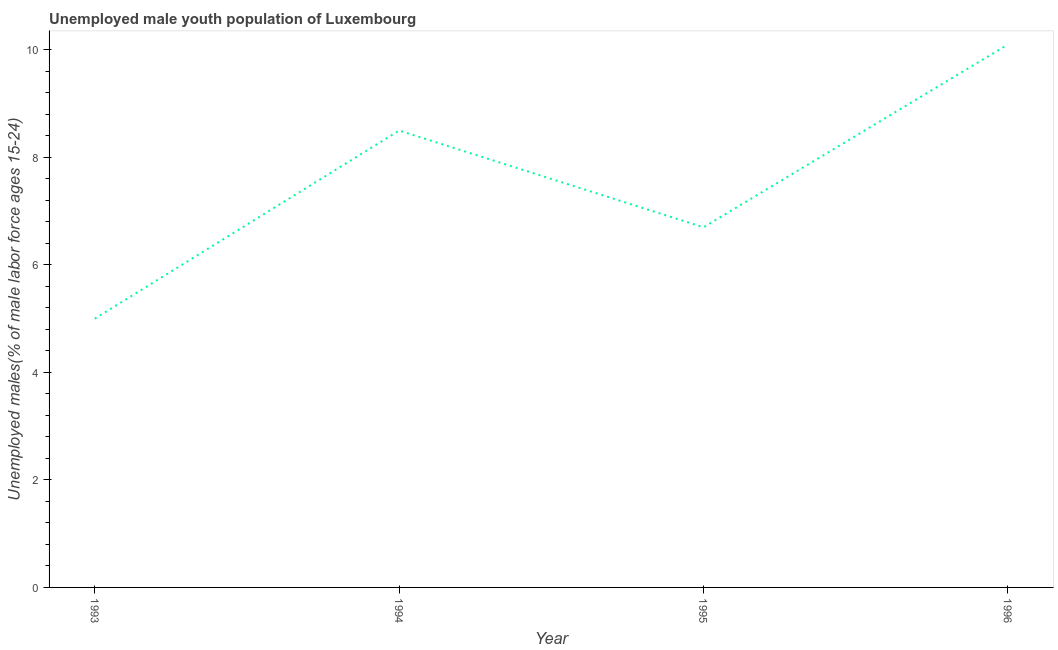Across all years, what is the maximum unemployed male youth?
Offer a terse response. 10.1. Across all years, what is the minimum unemployed male youth?
Give a very brief answer. 5. In which year was the unemployed male youth minimum?
Give a very brief answer. 1993. What is the sum of the unemployed male youth?
Your answer should be compact. 30.3. What is the difference between the unemployed male youth in 1994 and 1995?
Your response must be concise. 1.8. What is the average unemployed male youth per year?
Your answer should be compact. 7.58. What is the median unemployed male youth?
Offer a very short reply. 7.6. In how many years, is the unemployed male youth greater than 2 %?
Your answer should be very brief. 4. What is the ratio of the unemployed male youth in 1993 to that in 1996?
Provide a succinct answer. 0.5. Is the difference between the unemployed male youth in 1993 and 1994 greater than the difference between any two years?
Keep it short and to the point. No. What is the difference between the highest and the second highest unemployed male youth?
Ensure brevity in your answer.  1.6. Is the sum of the unemployed male youth in 1994 and 1996 greater than the maximum unemployed male youth across all years?
Offer a terse response. Yes. What is the difference between the highest and the lowest unemployed male youth?
Make the answer very short. 5.1. What is the title of the graph?
Provide a short and direct response. Unemployed male youth population of Luxembourg. What is the label or title of the Y-axis?
Offer a terse response. Unemployed males(% of male labor force ages 15-24). What is the Unemployed males(% of male labor force ages 15-24) in 1993?
Ensure brevity in your answer.  5. What is the Unemployed males(% of male labor force ages 15-24) of 1994?
Provide a short and direct response. 8.5. What is the Unemployed males(% of male labor force ages 15-24) of 1995?
Your answer should be very brief. 6.7. What is the Unemployed males(% of male labor force ages 15-24) in 1996?
Offer a terse response. 10.1. What is the difference between the Unemployed males(% of male labor force ages 15-24) in 1993 and 1996?
Provide a short and direct response. -5.1. What is the difference between the Unemployed males(% of male labor force ages 15-24) in 1994 and 1995?
Your response must be concise. 1.8. What is the difference between the Unemployed males(% of male labor force ages 15-24) in 1994 and 1996?
Your answer should be compact. -1.6. What is the difference between the Unemployed males(% of male labor force ages 15-24) in 1995 and 1996?
Your response must be concise. -3.4. What is the ratio of the Unemployed males(% of male labor force ages 15-24) in 1993 to that in 1994?
Offer a terse response. 0.59. What is the ratio of the Unemployed males(% of male labor force ages 15-24) in 1993 to that in 1995?
Your answer should be very brief. 0.75. What is the ratio of the Unemployed males(% of male labor force ages 15-24) in 1993 to that in 1996?
Provide a succinct answer. 0.49. What is the ratio of the Unemployed males(% of male labor force ages 15-24) in 1994 to that in 1995?
Your response must be concise. 1.27. What is the ratio of the Unemployed males(% of male labor force ages 15-24) in 1994 to that in 1996?
Make the answer very short. 0.84. What is the ratio of the Unemployed males(% of male labor force ages 15-24) in 1995 to that in 1996?
Your response must be concise. 0.66. 